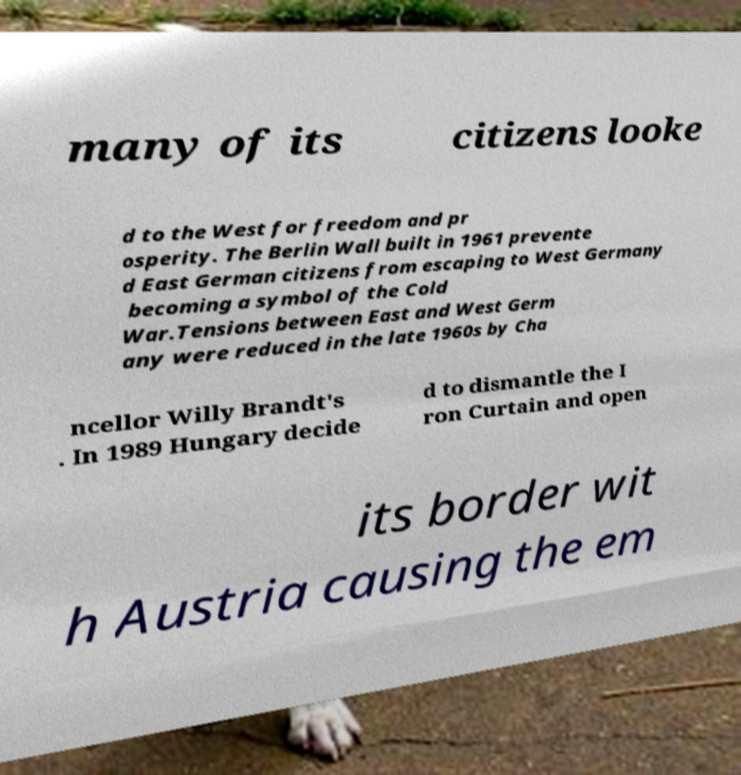Can you read and provide the text displayed in the image?This photo seems to have some interesting text. Can you extract and type it out for me? many of its citizens looke d to the West for freedom and pr osperity. The Berlin Wall built in 1961 prevente d East German citizens from escaping to West Germany becoming a symbol of the Cold War.Tensions between East and West Germ any were reduced in the late 1960s by Cha ncellor Willy Brandt's . In 1989 Hungary decide d to dismantle the I ron Curtain and open its border wit h Austria causing the em 